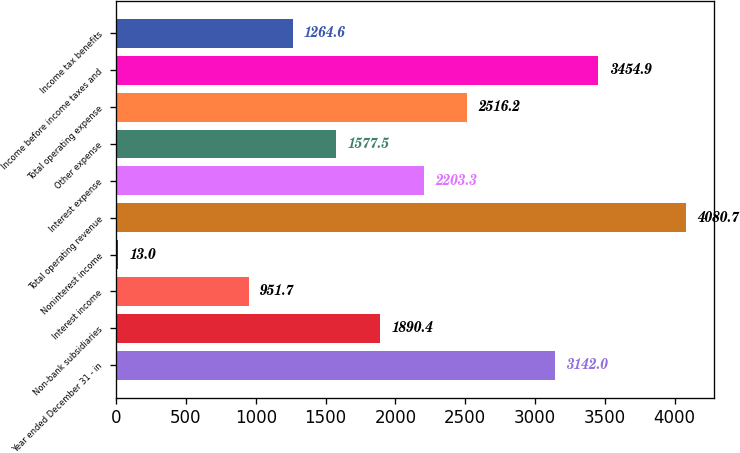<chart> <loc_0><loc_0><loc_500><loc_500><bar_chart><fcel>Year ended December 31 - in<fcel>Non-bank subsidiaries<fcel>Interest income<fcel>Noninterest income<fcel>Total operating revenue<fcel>Interest expense<fcel>Other expense<fcel>Total operating expense<fcel>Income before income taxes and<fcel>Income tax benefits<nl><fcel>3142<fcel>1890.4<fcel>951.7<fcel>13<fcel>4080.7<fcel>2203.3<fcel>1577.5<fcel>2516.2<fcel>3454.9<fcel>1264.6<nl></chart> 